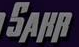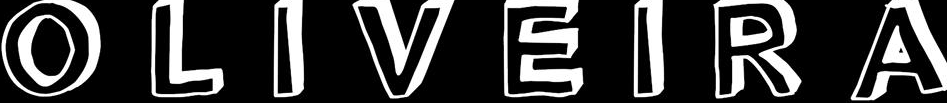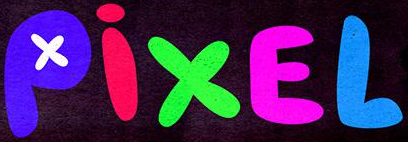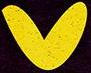What text appears in these images from left to right, separated by a semicolon? SAHR; OLIVEIRA; PixEL; v 